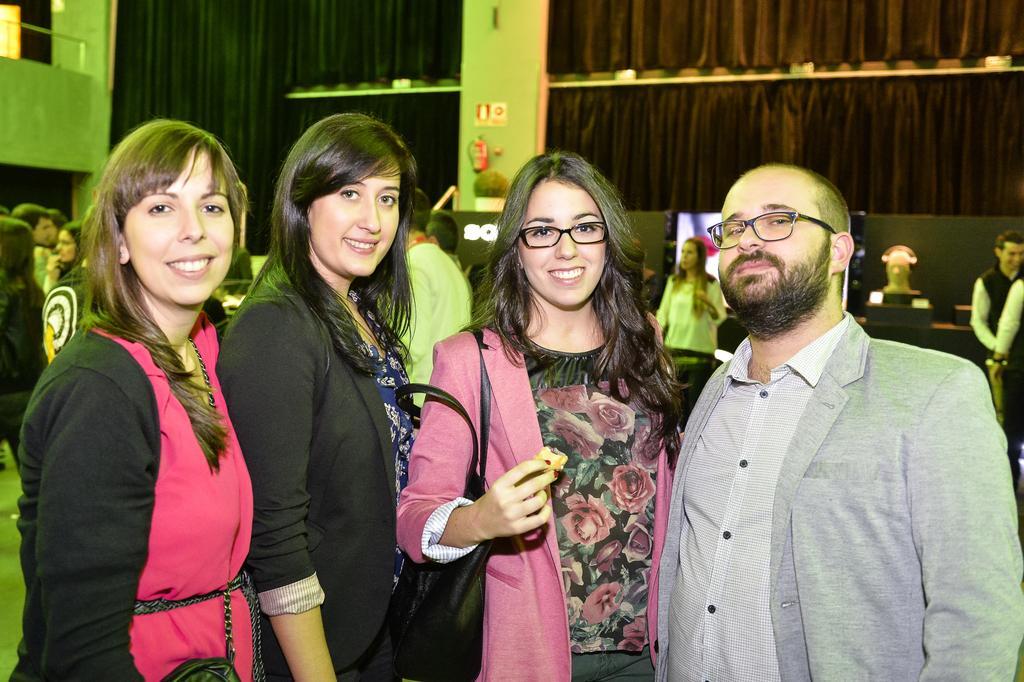In one or two sentences, can you explain what this image depicts? In the center of the image we can see four people are standing and they are smiling, which we can see on their faces. Among them, we can see two persons are wearing glasses and one person is holding a handbag and some other object. In the background there is a wall, pillar, fence, screen, table, mannequin head, curtains, banners, few people are standing, few people are holding some objects and a few other objects. 